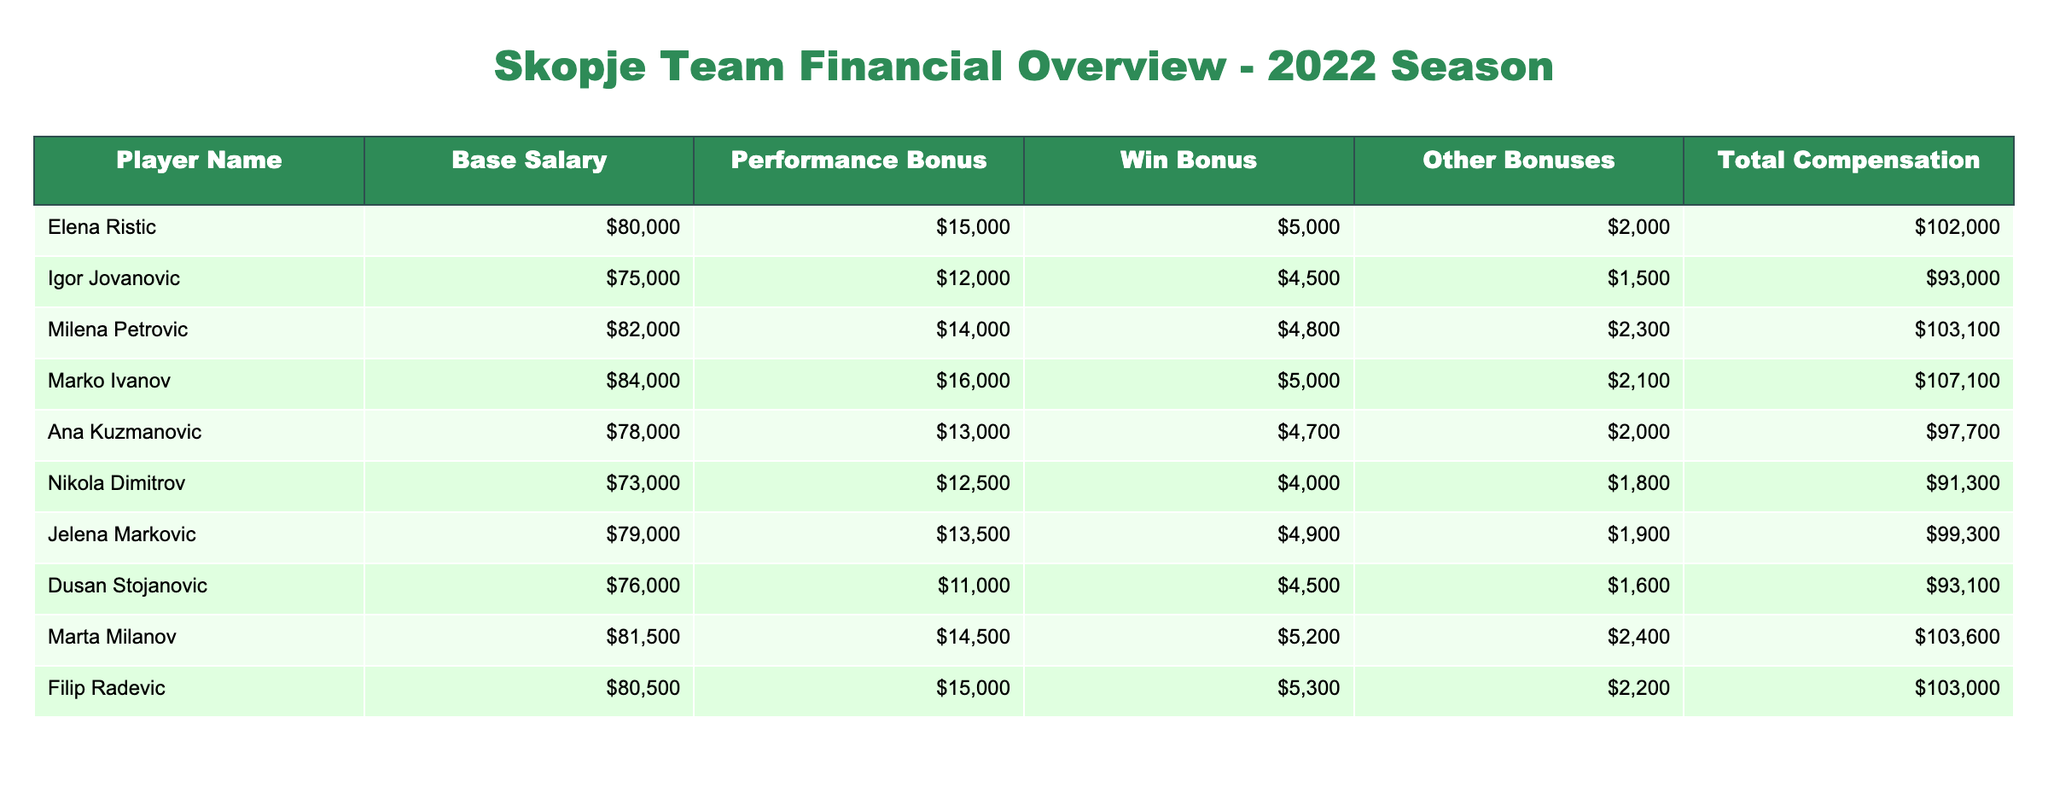What is the highest total compensation among the players? Looking at the "Total Compensation" column, the values for total compensation are 102000, 93000, 103100, 107100, 97700, 91300, 99300, 93100, 103600, and 103000. The highest value is 107100, associated with Marko Ivanov.
Answer: 107100 Which player has the lowest base salary? In the "Base Salary" column, the salaries are 80000, 75000, 82000, 84000, 78000, 73000, 79000, 76000, 81500, and 80500. The lowest salary is 73000, attributed to Nikola Dimitrov.
Answer: 73000 What is the average performance bonus for the Skopje team? The performance bonuses are 15000, 12000, 14000, 16000, 13000, 12500, 13500, 11000, 14500, and 15000. First, sum them: 15000 + 12000 + 14000 + 16000 + 13000 + 12500 + 13500 + 11000 + 14500 + 15000 = 138000. Then, divide by the number of players (10): 138000 / 10 = 13800.
Answer: 13800 Is there any player whose total compensation exceeds 100000? Examining the "Total Compensation" column, the values are 102000, 93000, 103100, 107100, 97700, 91300, 99300, 93100, 103600, and 103000. The values of 102000, 103100, 107100, 103600, and 103000 all exceed 100000, so the answer is yes.
Answer: Yes What is the difference between the highest and lowest win bonuses? The win bonuses are 5000, 4500, 4800, 5000, 4700, 4000, 4900, 4500, 5200, and 5300. The highest is 5300 and the lowest is 4000. The difference is 5300 - 4000 = 1300.
Answer: 1300 Which player has the highest performance bonus? Looking at the "Performance Bonus" column, the values are 15000, 12000, 14000, 16000, 13000, 12500, 13500, 11000, 14500, and 15000. The highest bonus is 16000, corresponding to Marko Ivanov.
Answer: Marko Ivanov What percentage of total salary for Ana Kuzmanovic comes from bonuses? First, find Ana's base salary (78000) and total compensation (97700). Calculate total bonuses by subtracting the base salary from the total: 97700 - 78000 = 19700. To find the percentage, do (19700 / 97700) * 100 = approximately 20.16%.
Answer: 20.16% Did any player have a performance bonus less than 13000? Analyzing the "Performance Bonus" column, the bonuses listed are 15000, 12000, 14000, 16000, 13000, 12500, 13500, 11000, 14500, and 15000. The bonuses of 12000, 12500, and 11000 are all less than 13000. Therefore, the answer is yes.
Answer: Yes 